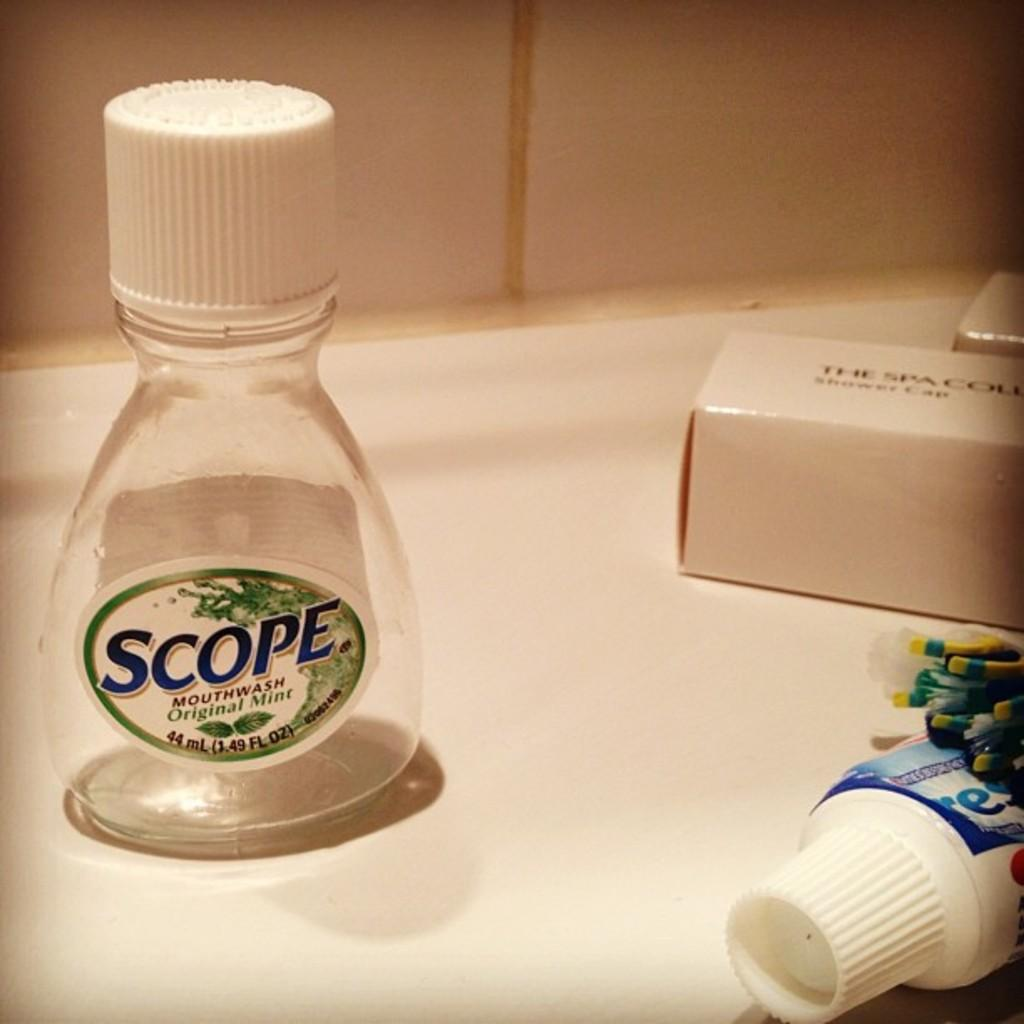<image>
Create a compact narrative representing the image presented. Scope mouthwash on top of a sink and next to a Crest toothpaste. 